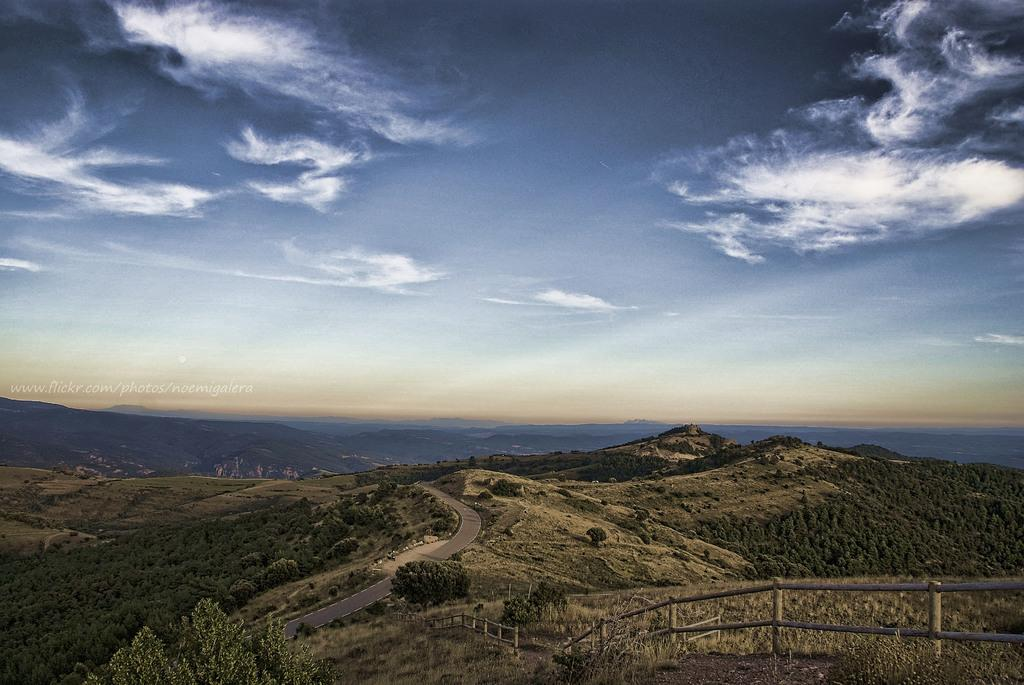What type of barrier can be seen in the image? There is a fence in the image. What type of natural vegetation is present in the image? There are trees in the image. What type of geographical feature is visible in the image? There are mountains in the image. What type of text is present in the image? There is a text in the image. What part of the natural environment is visible in the image? The sky is visible at the top of the image. Can you describe the possible location of the image based on the visible features? The image may have been taken near the mountains. Where is the dad sitting in the image? There is no dad present in the image. What type of territory is being claimed by the fence in the image? The image does not indicate any territorial claims; it simply shows a fence. 